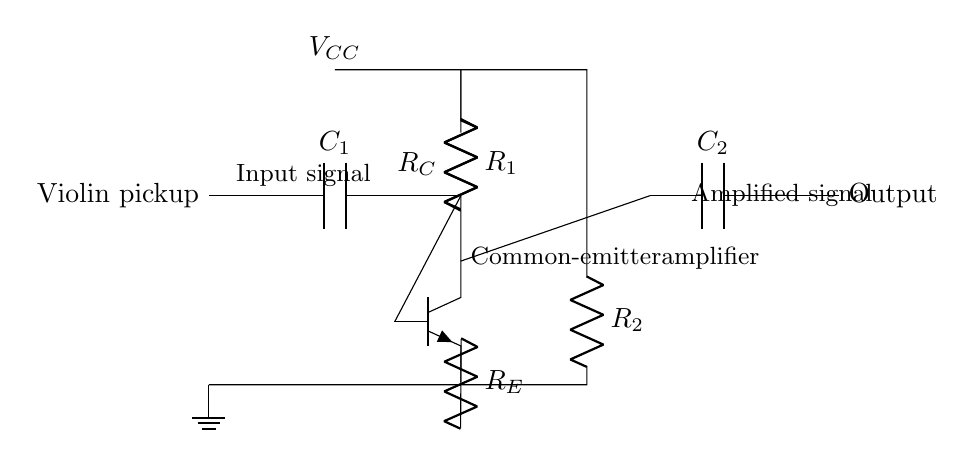What is the purpose of the capacitor C1? Capacitor C1 is used to couple the input signal from the violin pickup while blocking any DC component, allowing only the AC audio signal to pass through to the transistor.
Answer: Coupling What type of amplifier is represented in this circuit? The circuit is a common-emitter amplifier, which utilizes a transistor to amplify the input signal. This type of configuration is known for providing good voltage gain.
Answer: Common-emitter What is the function of the resistor R_E? Resistor R_E provides emitter stabilization, which helps to improve the linearity and thermal stability of the amplifier circuit, ensuring consistent performance over varying conditions.
Answer: Stabilization What does the output node represent? The output node is the point where the amplified signal is taken from the circuit, following the amplification process across the transistor. It is the connection to the following stage or device.
Answer: Amplified signal Where is the power supply connected in this circuit? The power supply, denoted as V_CC, is connected to the collector of the transistor, providing the necessary voltage for the amplification process to take place.
Answer: Collector What role does the capacitor C2 play in the output? Capacitor C2 is used for coupling the amplified audio signal to the output, allowing the AC signal to pass while blocking any DC offset, ensuring that the next stage does not receive unwanted DC.
Answer: Coupling 